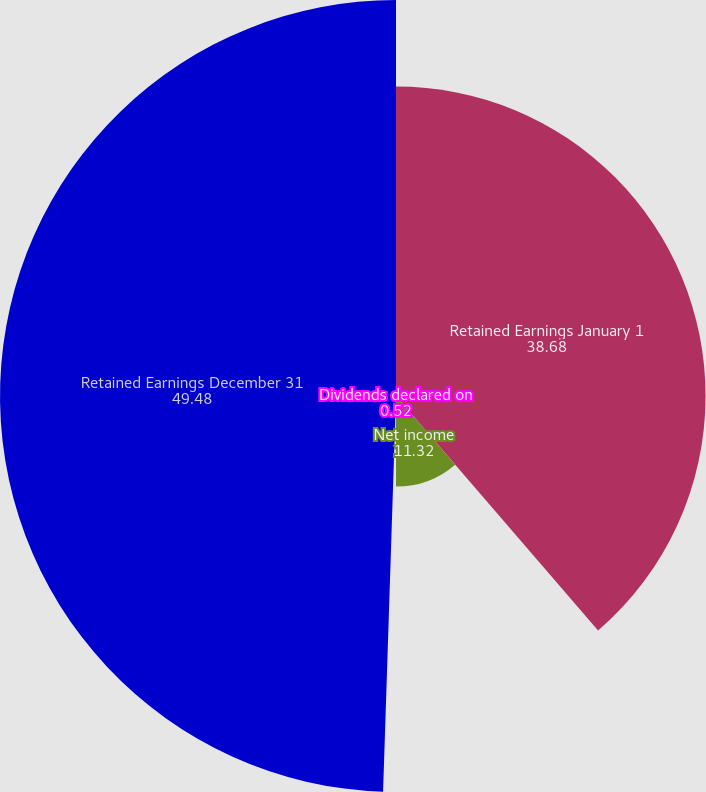Convert chart. <chart><loc_0><loc_0><loc_500><loc_500><pie_chart><fcel>Retained Earnings January 1<fcel>Net income<fcel>Dividends declared on<fcel>Retained Earnings December 31<nl><fcel>38.68%<fcel>11.32%<fcel>0.52%<fcel>49.48%<nl></chart> 